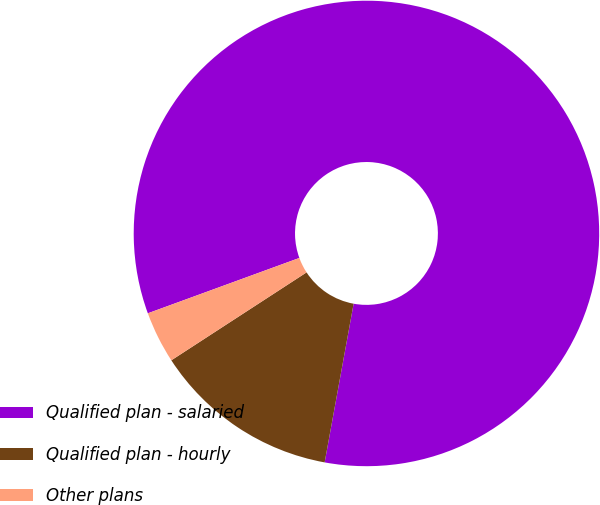<chart> <loc_0><loc_0><loc_500><loc_500><pie_chart><fcel>Qualified plan - salaried<fcel>Qualified plan - hourly<fcel>Other plans<nl><fcel>83.45%<fcel>12.95%<fcel>3.6%<nl></chart> 